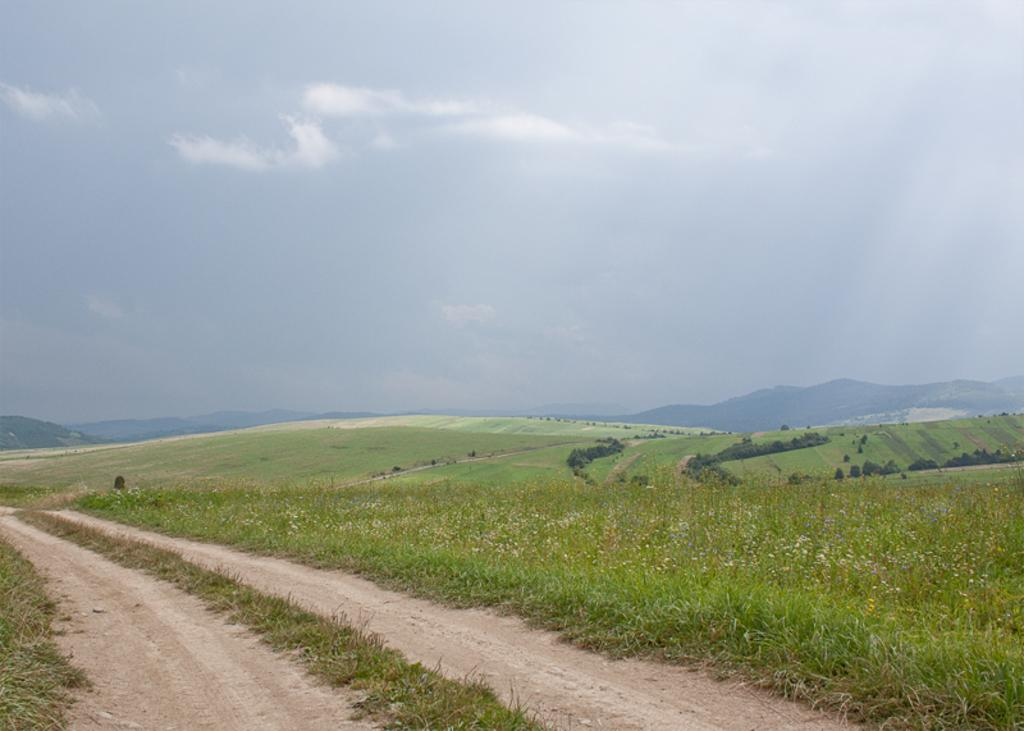What type of terrain is visible in the image? There is a road, grasslands, trees, and hills visible in the image. What can be seen in the background of the image? The sky is visible in the background of the image, with clouds present. How many bikes are parked near the trees in the image? There are no bikes present in the image. What type of quartz can be seen embedded in the hills in the image? There is no quartz visible in the image, and the hills are not described as having any specific minerals or geological features. 